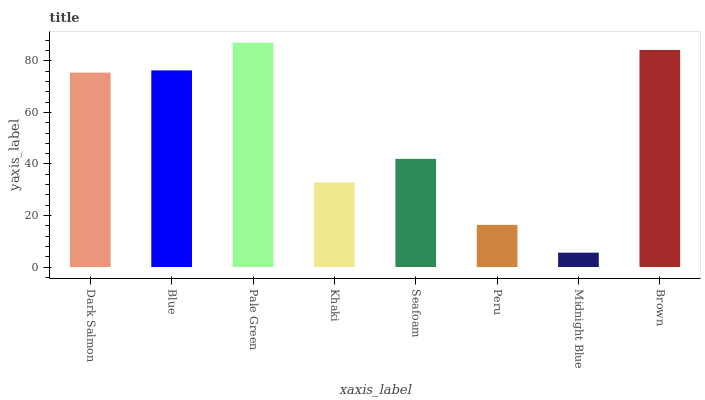Is Midnight Blue the minimum?
Answer yes or no. Yes. Is Pale Green the maximum?
Answer yes or no. Yes. Is Blue the minimum?
Answer yes or no. No. Is Blue the maximum?
Answer yes or no. No. Is Blue greater than Dark Salmon?
Answer yes or no. Yes. Is Dark Salmon less than Blue?
Answer yes or no. Yes. Is Dark Salmon greater than Blue?
Answer yes or no. No. Is Blue less than Dark Salmon?
Answer yes or no. No. Is Dark Salmon the high median?
Answer yes or no. Yes. Is Seafoam the low median?
Answer yes or no. Yes. Is Brown the high median?
Answer yes or no. No. Is Midnight Blue the low median?
Answer yes or no. No. 